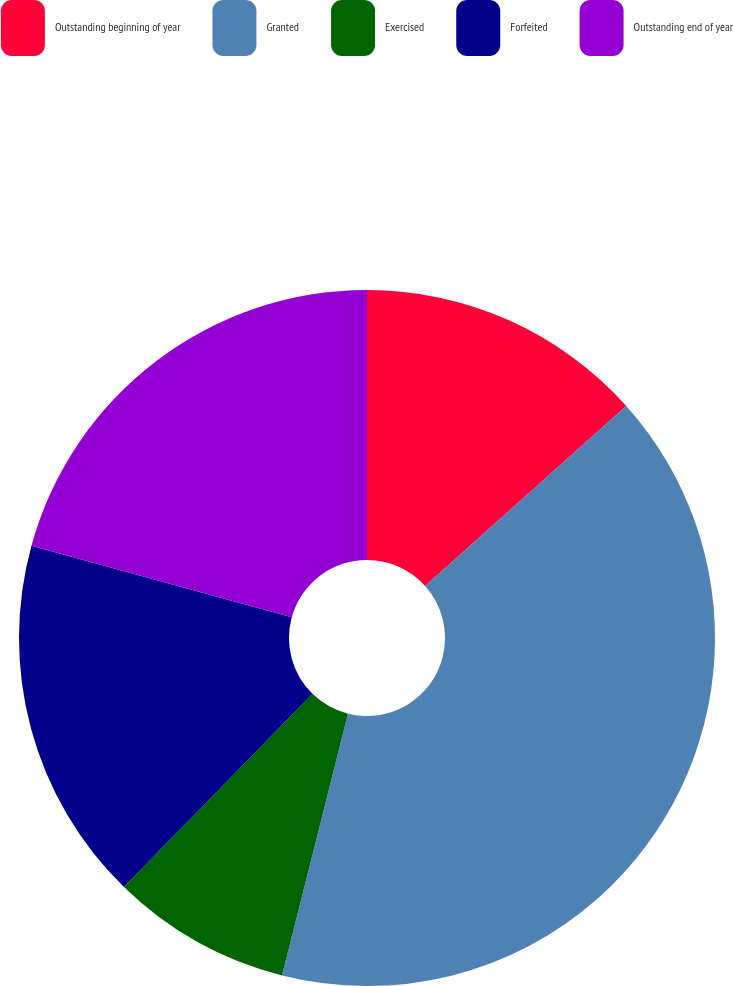Convert chart. <chart><loc_0><loc_0><loc_500><loc_500><pie_chart><fcel>Outstanding beginning of year<fcel>Granted<fcel>Exercised<fcel>Forfeited<fcel>Outstanding end of year<nl><fcel>13.38%<fcel>40.55%<fcel>8.38%<fcel>16.97%<fcel>20.73%<nl></chart> 